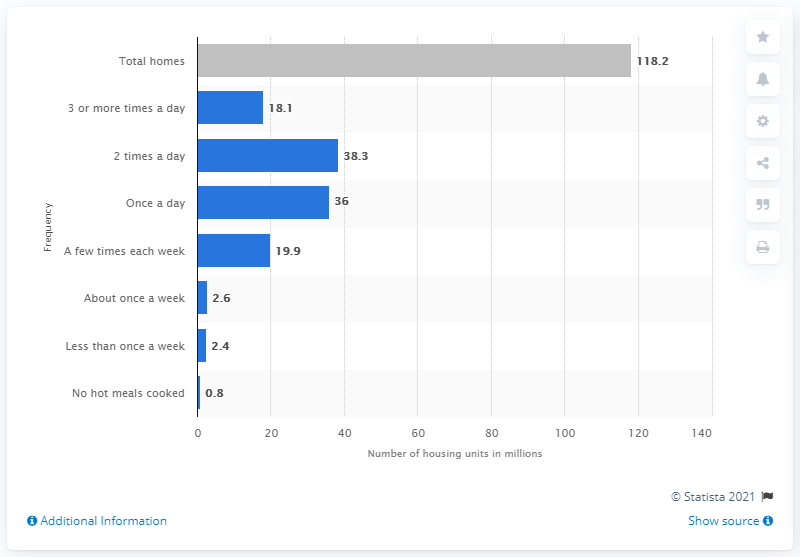Identify some key points in this picture. During the time period of August 2015 and April 2016, a total of 38.3 housing units were cooked twice a day. 